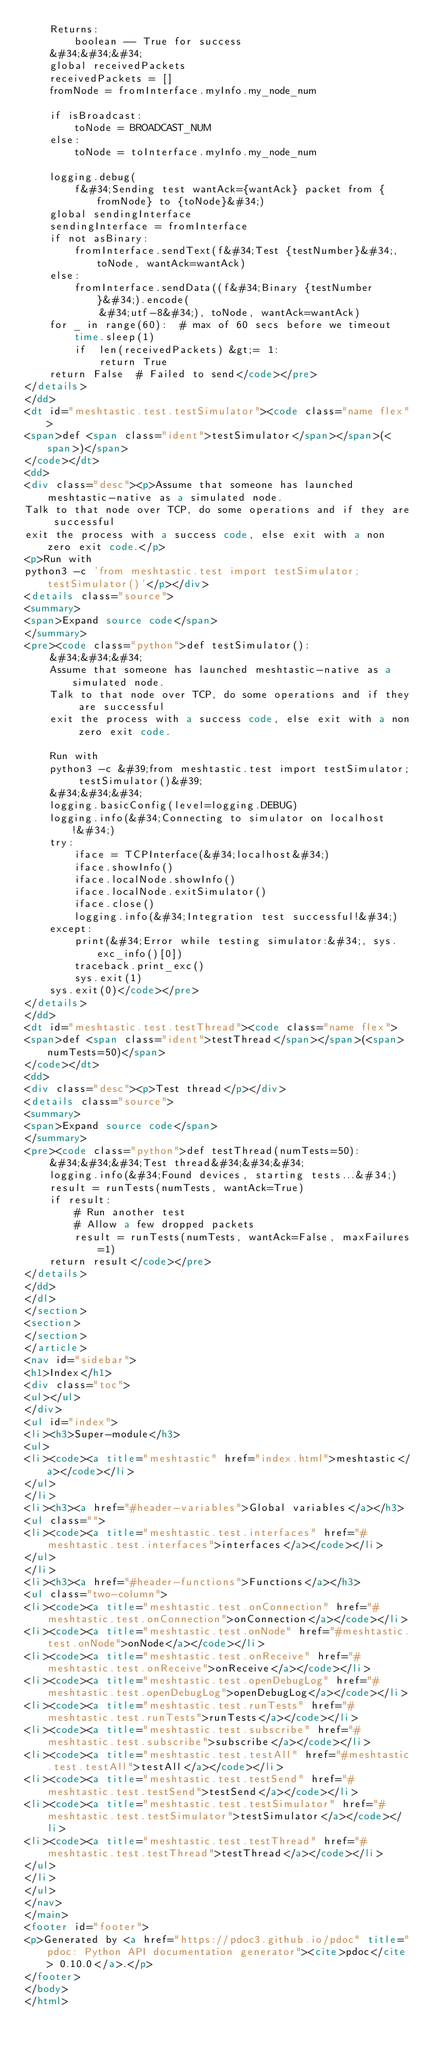<code> <loc_0><loc_0><loc_500><loc_500><_HTML_>    Returns:
        boolean -- True for success
    &#34;&#34;&#34;
    global receivedPackets
    receivedPackets = []
    fromNode = fromInterface.myInfo.my_node_num

    if isBroadcast:
        toNode = BROADCAST_NUM
    else:
        toNode = toInterface.myInfo.my_node_num

    logging.debug(
        f&#34;Sending test wantAck={wantAck} packet from {fromNode} to {toNode}&#34;)
    global sendingInterface
    sendingInterface = fromInterface
    if not asBinary:
        fromInterface.sendText(f&#34;Test {testNumber}&#34;, toNode, wantAck=wantAck)
    else:
        fromInterface.sendData((f&#34;Binary {testNumber}&#34;).encode(
            &#34;utf-8&#34;), toNode, wantAck=wantAck)
    for _ in range(60):  # max of 60 secs before we timeout
        time.sleep(1)
        if  len(receivedPackets) &gt;= 1:
            return True
    return False  # Failed to send</code></pre>
</details>
</dd>
<dt id="meshtastic.test.testSimulator"><code class="name flex">
<span>def <span class="ident">testSimulator</span></span>(<span>)</span>
</code></dt>
<dd>
<div class="desc"><p>Assume that someone has launched meshtastic-native as a simulated node.
Talk to that node over TCP, do some operations and if they are successful
exit the process with a success code, else exit with a non zero exit code.</p>
<p>Run with
python3 -c 'from meshtastic.test import testSimulator; testSimulator()'</p></div>
<details class="source">
<summary>
<span>Expand source code</span>
</summary>
<pre><code class="python">def testSimulator():
    &#34;&#34;&#34;
    Assume that someone has launched meshtastic-native as a simulated node.
    Talk to that node over TCP, do some operations and if they are successful
    exit the process with a success code, else exit with a non zero exit code.

    Run with
    python3 -c &#39;from meshtastic.test import testSimulator; testSimulator()&#39;
    &#34;&#34;&#34;
    logging.basicConfig(level=logging.DEBUG)
    logging.info(&#34;Connecting to simulator on localhost!&#34;)
    try:
        iface = TCPInterface(&#34;localhost&#34;)
        iface.showInfo()
        iface.localNode.showInfo()
        iface.localNode.exitSimulator()
        iface.close()
        logging.info(&#34;Integration test successful!&#34;)
    except:
        print(&#34;Error while testing simulator:&#34;, sys.exc_info()[0])
        traceback.print_exc()
        sys.exit(1)
    sys.exit(0)</code></pre>
</details>
</dd>
<dt id="meshtastic.test.testThread"><code class="name flex">
<span>def <span class="ident">testThread</span></span>(<span>numTests=50)</span>
</code></dt>
<dd>
<div class="desc"><p>Test thread</p></div>
<details class="source">
<summary>
<span>Expand source code</span>
</summary>
<pre><code class="python">def testThread(numTests=50):
    &#34;&#34;&#34;Test thread&#34;&#34;&#34;
    logging.info(&#34;Found devices, starting tests...&#34;)
    result = runTests(numTests, wantAck=True)
    if result:
        # Run another test
        # Allow a few dropped packets
        result = runTests(numTests, wantAck=False, maxFailures=1)
    return result</code></pre>
</details>
</dd>
</dl>
</section>
<section>
</section>
</article>
<nav id="sidebar">
<h1>Index</h1>
<div class="toc">
<ul></ul>
</div>
<ul id="index">
<li><h3>Super-module</h3>
<ul>
<li><code><a title="meshtastic" href="index.html">meshtastic</a></code></li>
</ul>
</li>
<li><h3><a href="#header-variables">Global variables</a></h3>
<ul class="">
<li><code><a title="meshtastic.test.interfaces" href="#meshtastic.test.interfaces">interfaces</a></code></li>
</ul>
</li>
<li><h3><a href="#header-functions">Functions</a></h3>
<ul class="two-column">
<li><code><a title="meshtastic.test.onConnection" href="#meshtastic.test.onConnection">onConnection</a></code></li>
<li><code><a title="meshtastic.test.onNode" href="#meshtastic.test.onNode">onNode</a></code></li>
<li><code><a title="meshtastic.test.onReceive" href="#meshtastic.test.onReceive">onReceive</a></code></li>
<li><code><a title="meshtastic.test.openDebugLog" href="#meshtastic.test.openDebugLog">openDebugLog</a></code></li>
<li><code><a title="meshtastic.test.runTests" href="#meshtastic.test.runTests">runTests</a></code></li>
<li><code><a title="meshtastic.test.subscribe" href="#meshtastic.test.subscribe">subscribe</a></code></li>
<li><code><a title="meshtastic.test.testAll" href="#meshtastic.test.testAll">testAll</a></code></li>
<li><code><a title="meshtastic.test.testSend" href="#meshtastic.test.testSend">testSend</a></code></li>
<li><code><a title="meshtastic.test.testSimulator" href="#meshtastic.test.testSimulator">testSimulator</a></code></li>
<li><code><a title="meshtastic.test.testThread" href="#meshtastic.test.testThread">testThread</a></code></li>
</ul>
</li>
</ul>
</nav>
</main>
<footer id="footer">
<p>Generated by <a href="https://pdoc3.github.io/pdoc" title="pdoc: Python API documentation generator"><cite>pdoc</cite> 0.10.0</a>.</p>
</footer>
</body>
</html></code> 